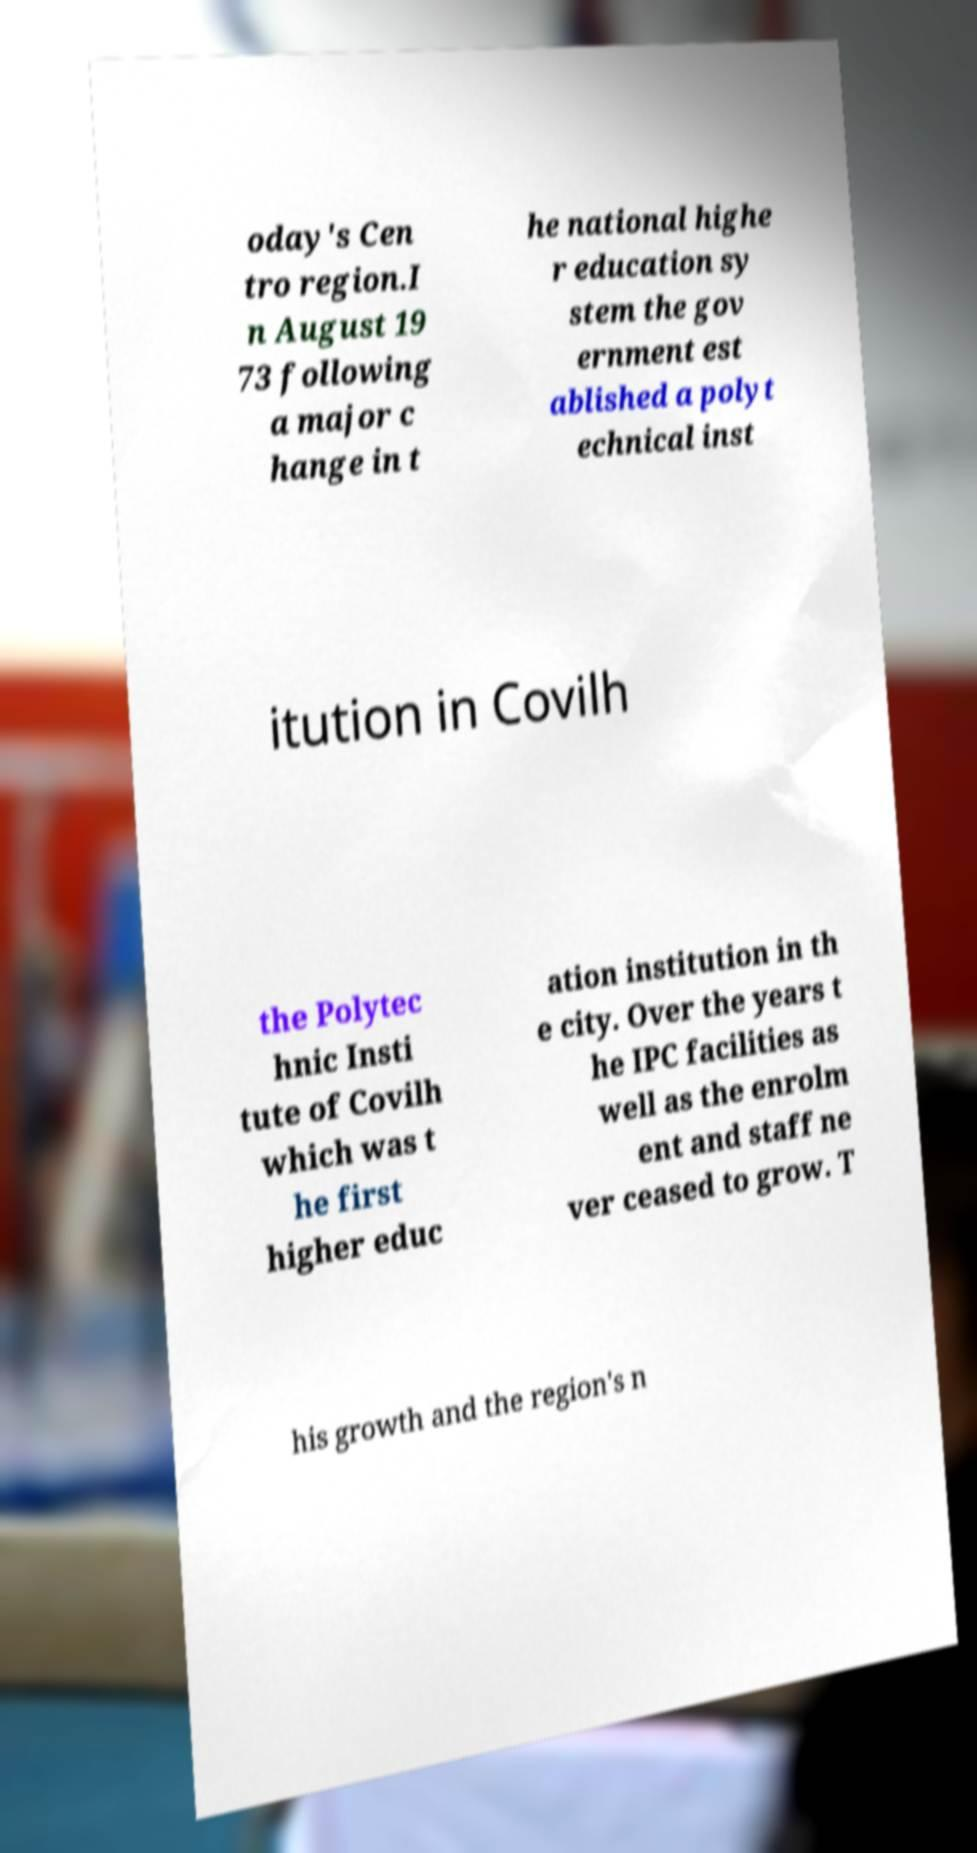For documentation purposes, I need the text within this image transcribed. Could you provide that? oday's Cen tro region.I n August 19 73 following a major c hange in t he national highe r education sy stem the gov ernment est ablished a polyt echnical inst itution in Covilh the Polytec hnic Insti tute of Covilh which was t he first higher educ ation institution in th e city. Over the years t he IPC facilities as well as the enrolm ent and staff ne ver ceased to grow. T his growth and the region's n 